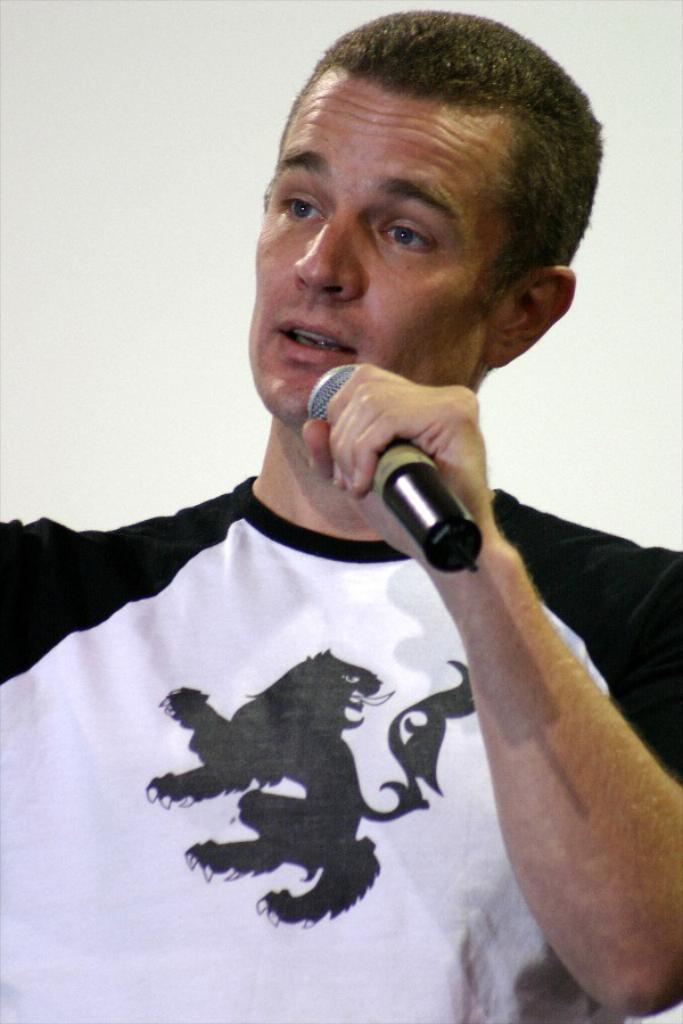In one or two sentences, can you explain what this image depicts? In the center of the image, we can see a person holding a mic. In the background, there is a wall. 